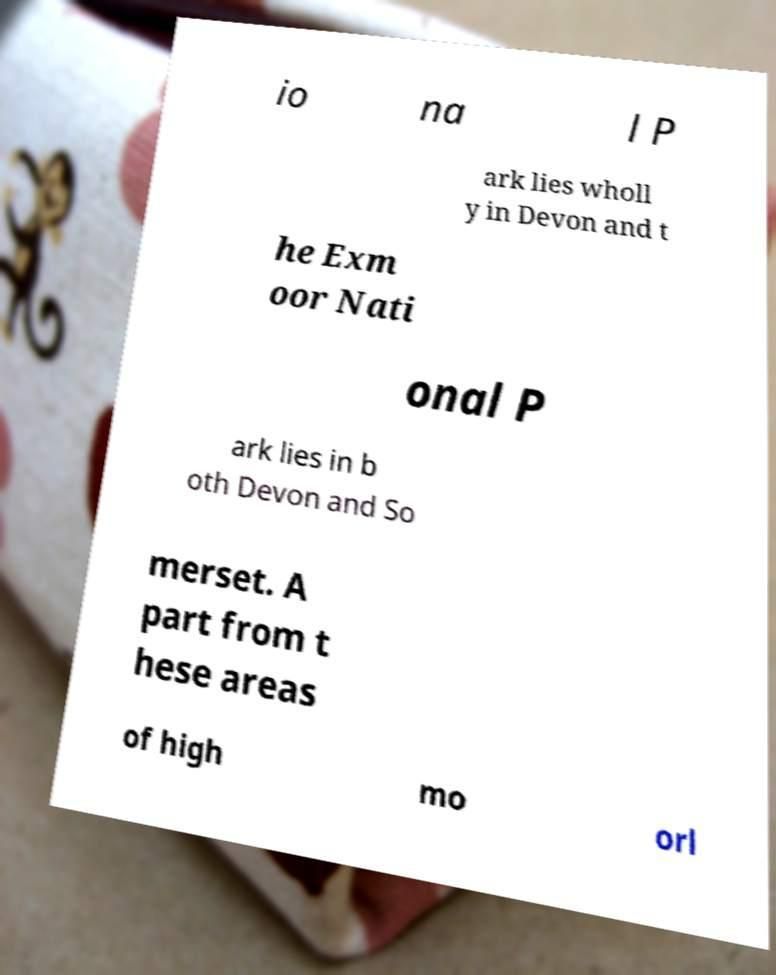Can you read and provide the text displayed in the image?This photo seems to have some interesting text. Can you extract and type it out for me? io na l P ark lies wholl y in Devon and t he Exm oor Nati onal P ark lies in b oth Devon and So merset. A part from t hese areas of high mo orl 